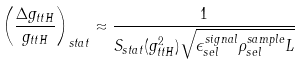<formula> <loc_0><loc_0><loc_500><loc_500>\left ( \frac { \Delta g _ { t t H } } { g _ { t t H } } \right ) _ { s t a t } \approx \frac { 1 } { S _ { s t a t } ( g ^ { 2 } _ { t t H } ) \sqrt { \epsilon _ { s e l } ^ { s i g n a l } \rho _ { s e l } ^ { s a m p l e } L } }</formula> 